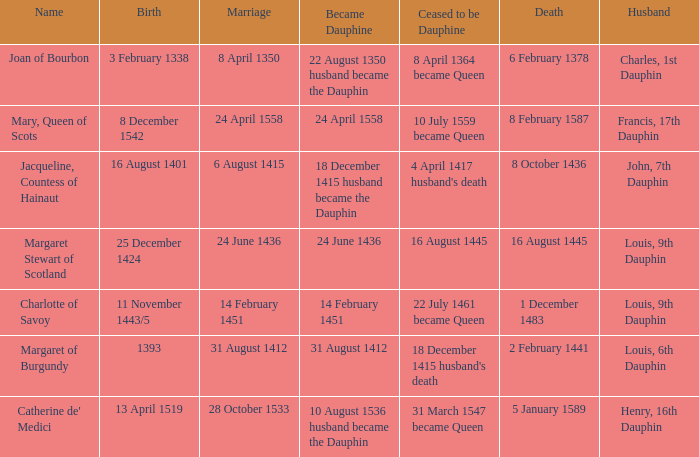When was became dauphine when birth is 1393? 31 August 1412. 